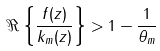Convert formula to latex. <formula><loc_0><loc_0><loc_500><loc_500>\Re \left \{ \frac { f ( z ) } { k _ { m } ( z ) } \right \} > 1 - \frac { 1 } { \theta _ { m } }</formula> 